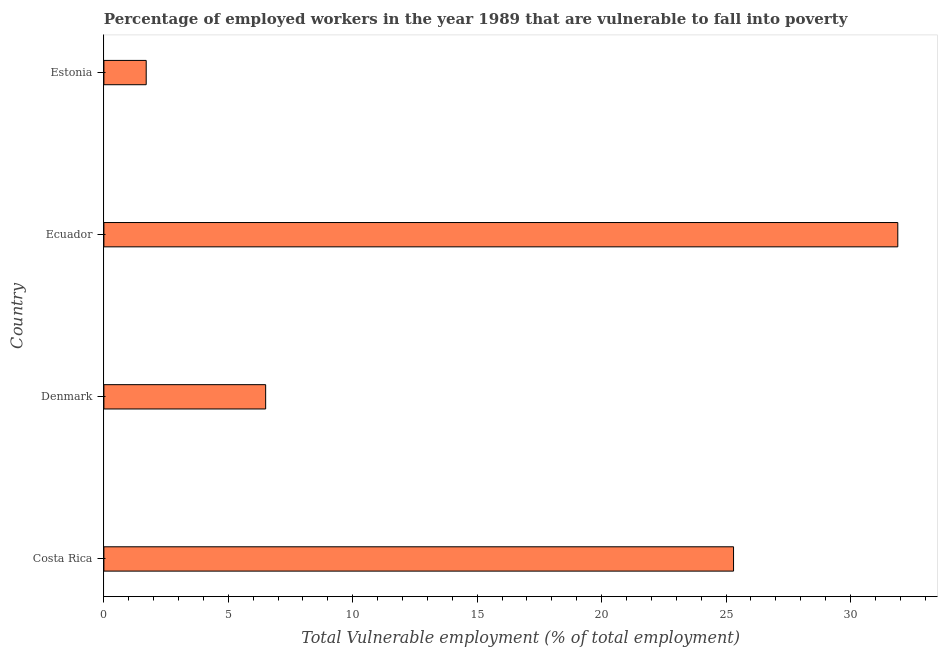Does the graph contain grids?
Provide a short and direct response. No. What is the title of the graph?
Provide a short and direct response. Percentage of employed workers in the year 1989 that are vulnerable to fall into poverty. What is the label or title of the X-axis?
Offer a terse response. Total Vulnerable employment (% of total employment). What is the label or title of the Y-axis?
Provide a short and direct response. Country. What is the total vulnerable employment in Costa Rica?
Your answer should be compact. 25.3. Across all countries, what is the maximum total vulnerable employment?
Offer a terse response. 31.9. Across all countries, what is the minimum total vulnerable employment?
Give a very brief answer. 1.7. In which country was the total vulnerable employment maximum?
Make the answer very short. Ecuador. In which country was the total vulnerable employment minimum?
Give a very brief answer. Estonia. What is the sum of the total vulnerable employment?
Provide a short and direct response. 65.4. What is the difference between the total vulnerable employment in Costa Rica and Denmark?
Offer a very short reply. 18.8. What is the average total vulnerable employment per country?
Offer a terse response. 16.35. What is the median total vulnerable employment?
Your answer should be very brief. 15.9. What is the ratio of the total vulnerable employment in Ecuador to that in Estonia?
Provide a succinct answer. 18.77. Is the difference between the total vulnerable employment in Denmark and Estonia greater than the difference between any two countries?
Provide a succinct answer. No. Is the sum of the total vulnerable employment in Ecuador and Estonia greater than the maximum total vulnerable employment across all countries?
Keep it short and to the point. Yes. What is the difference between the highest and the lowest total vulnerable employment?
Your answer should be compact. 30.2. In how many countries, is the total vulnerable employment greater than the average total vulnerable employment taken over all countries?
Provide a succinct answer. 2. How many bars are there?
Give a very brief answer. 4. Are all the bars in the graph horizontal?
Offer a very short reply. Yes. How many countries are there in the graph?
Offer a very short reply. 4. Are the values on the major ticks of X-axis written in scientific E-notation?
Make the answer very short. No. What is the Total Vulnerable employment (% of total employment) of Costa Rica?
Your response must be concise. 25.3. What is the Total Vulnerable employment (% of total employment) in Denmark?
Give a very brief answer. 6.5. What is the Total Vulnerable employment (% of total employment) in Ecuador?
Your answer should be compact. 31.9. What is the Total Vulnerable employment (% of total employment) of Estonia?
Offer a terse response. 1.7. What is the difference between the Total Vulnerable employment (% of total employment) in Costa Rica and Denmark?
Provide a succinct answer. 18.8. What is the difference between the Total Vulnerable employment (% of total employment) in Costa Rica and Ecuador?
Offer a very short reply. -6.6. What is the difference between the Total Vulnerable employment (% of total employment) in Costa Rica and Estonia?
Make the answer very short. 23.6. What is the difference between the Total Vulnerable employment (% of total employment) in Denmark and Ecuador?
Your answer should be very brief. -25.4. What is the difference between the Total Vulnerable employment (% of total employment) in Denmark and Estonia?
Give a very brief answer. 4.8. What is the difference between the Total Vulnerable employment (% of total employment) in Ecuador and Estonia?
Your answer should be compact. 30.2. What is the ratio of the Total Vulnerable employment (% of total employment) in Costa Rica to that in Denmark?
Keep it short and to the point. 3.89. What is the ratio of the Total Vulnerable employment (% of total employment) in Costa Rica to that in Ecuador?
Your answer should be compact. 0.79. What is the ratio of the Total Vulnerable employment (% of total employment) in Costa Rica to that in Estonia?
Provide a succinct answer. 14.88. What is the ratio of the Total Vulnerable employment (% of total employment) in Denmark to that in Ecuador?
Provide a succinct answer. 0.2. What is the ratio of the Total Vulnerable employment (% of total employment) in Denmark to that in Estonia?
Provide a succinct answer. 3.82. What is the ratio of the Total Vulnerable employment (% of total employment) in Ecuador to that in Estonia?
Provide a short and direct response. 18.77. 